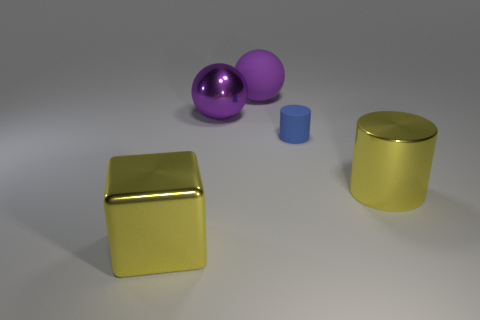Add 3 small purple matte cubes. How many objects exist? 8 Subtract all balls. How many objects are left? 3 Subtract all purple metallic spheres. Subtract all large cyan shiny things. How many objects are left? 4 Add 3 cylinders. How many cylinders are left? 5 Add 2 large yellow metal cylinders. How many large yellow metal cylinders exist? 3 Subtract 0 brown cubes. How many objects are left? 5 Subtract all purple blocks. Subtract all purple cylinders. How many blocks are left? 1 